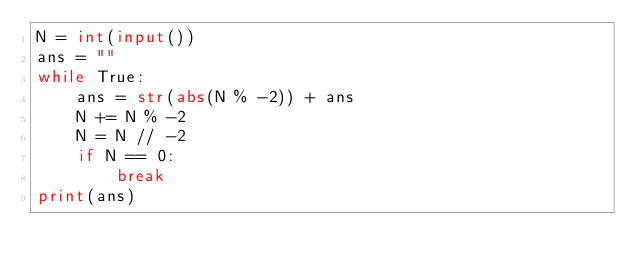<code> <loc_0><loc_0><loc_500><loc_500><_Python_>N = int(input())
ans = ""
while True:
    ans = str(abs(N % -2)) + ans
    N += N % -2
    N = N // -2
    if N == 0:
        break
print(ans)</code> 